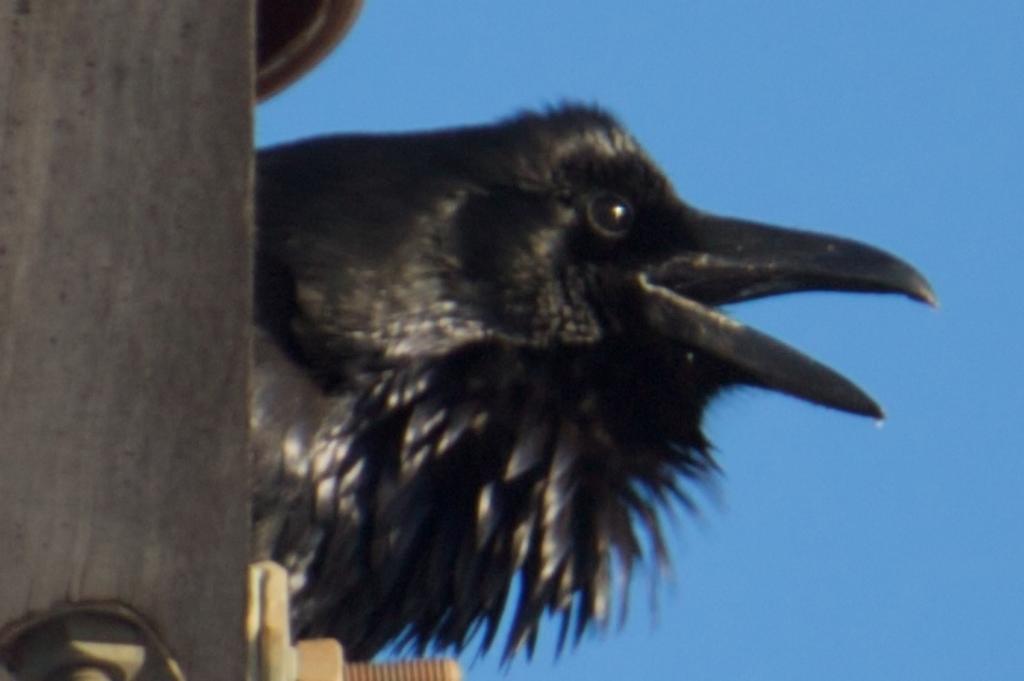How would you summarize this image in a sentence or two? In this image there is a black color bird in the middle of this image. There is one object is on the left side it seems like a current pole. There is a blue color sky in the background. 